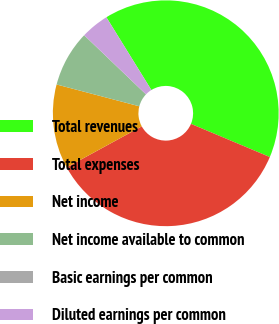Convert chart. <chart><loc_0><loc_0><loc_500><loc_500><pie_chart><fcel>Total revenues<fcel>Total expenses<fcel>Net income<fcel>Net income available to common<fcel>Basic earnings per common<fcel>Diluted earnings per common<nl><fcel>40.16%<fcel>35.71%<fcel>12.06%<fcel>8.04%<fcel>0.01%<fcel>4.03%<nl></chart> 